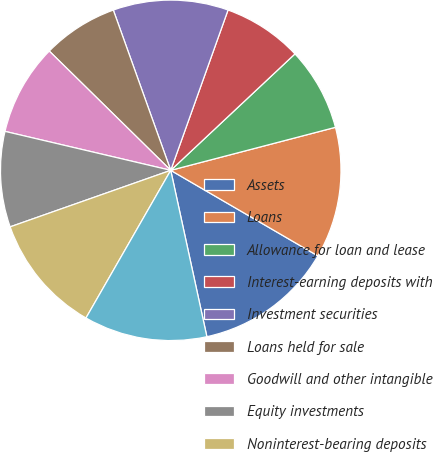<chart> <loc_0><loc_0><loc_500><loc_500><pie_chart><fcel>Assets<fcel>Loans<fcel>Allowance for loan and lease<fcel>Interest-earning deposits with<fcel>Investment securities<fcel>Loans held for sale<fcel>Goodwill and other intangible<fcel>Equity investments<fcel>Noninterest-bearing deposits<fcel>Interest-bearing deposits<nl><fcel>13.21%<fcel>12.45%<fcel>7.92%<fcel>7.55%<fcel>10.94%<fcel>7.17%<fcel>8.68%<fcel>9.06%<fcel>11.32%<fcel>11.7%<nl></chart> 